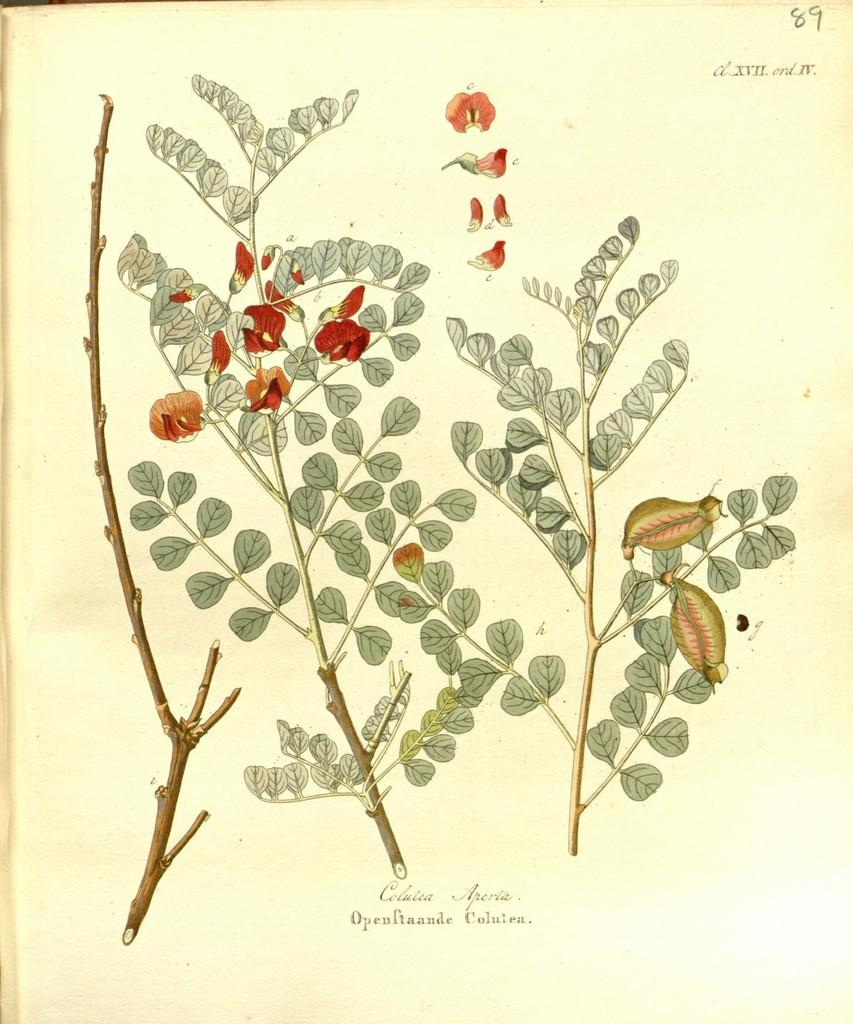What is the main subject of the painting in the image? The main subject of the painting in the image is branches and leaves. Is there any text associated with the painting? Yes, there is some text present in the image. Can you see a tiger hiding among the branches in the painting? No, there is no tiger present in the painting; it features branches and leaves. What trick is the artist using to convey their idea in the painting? The provided facts do not mention any tricks or ideas used by the artist in the painting. 